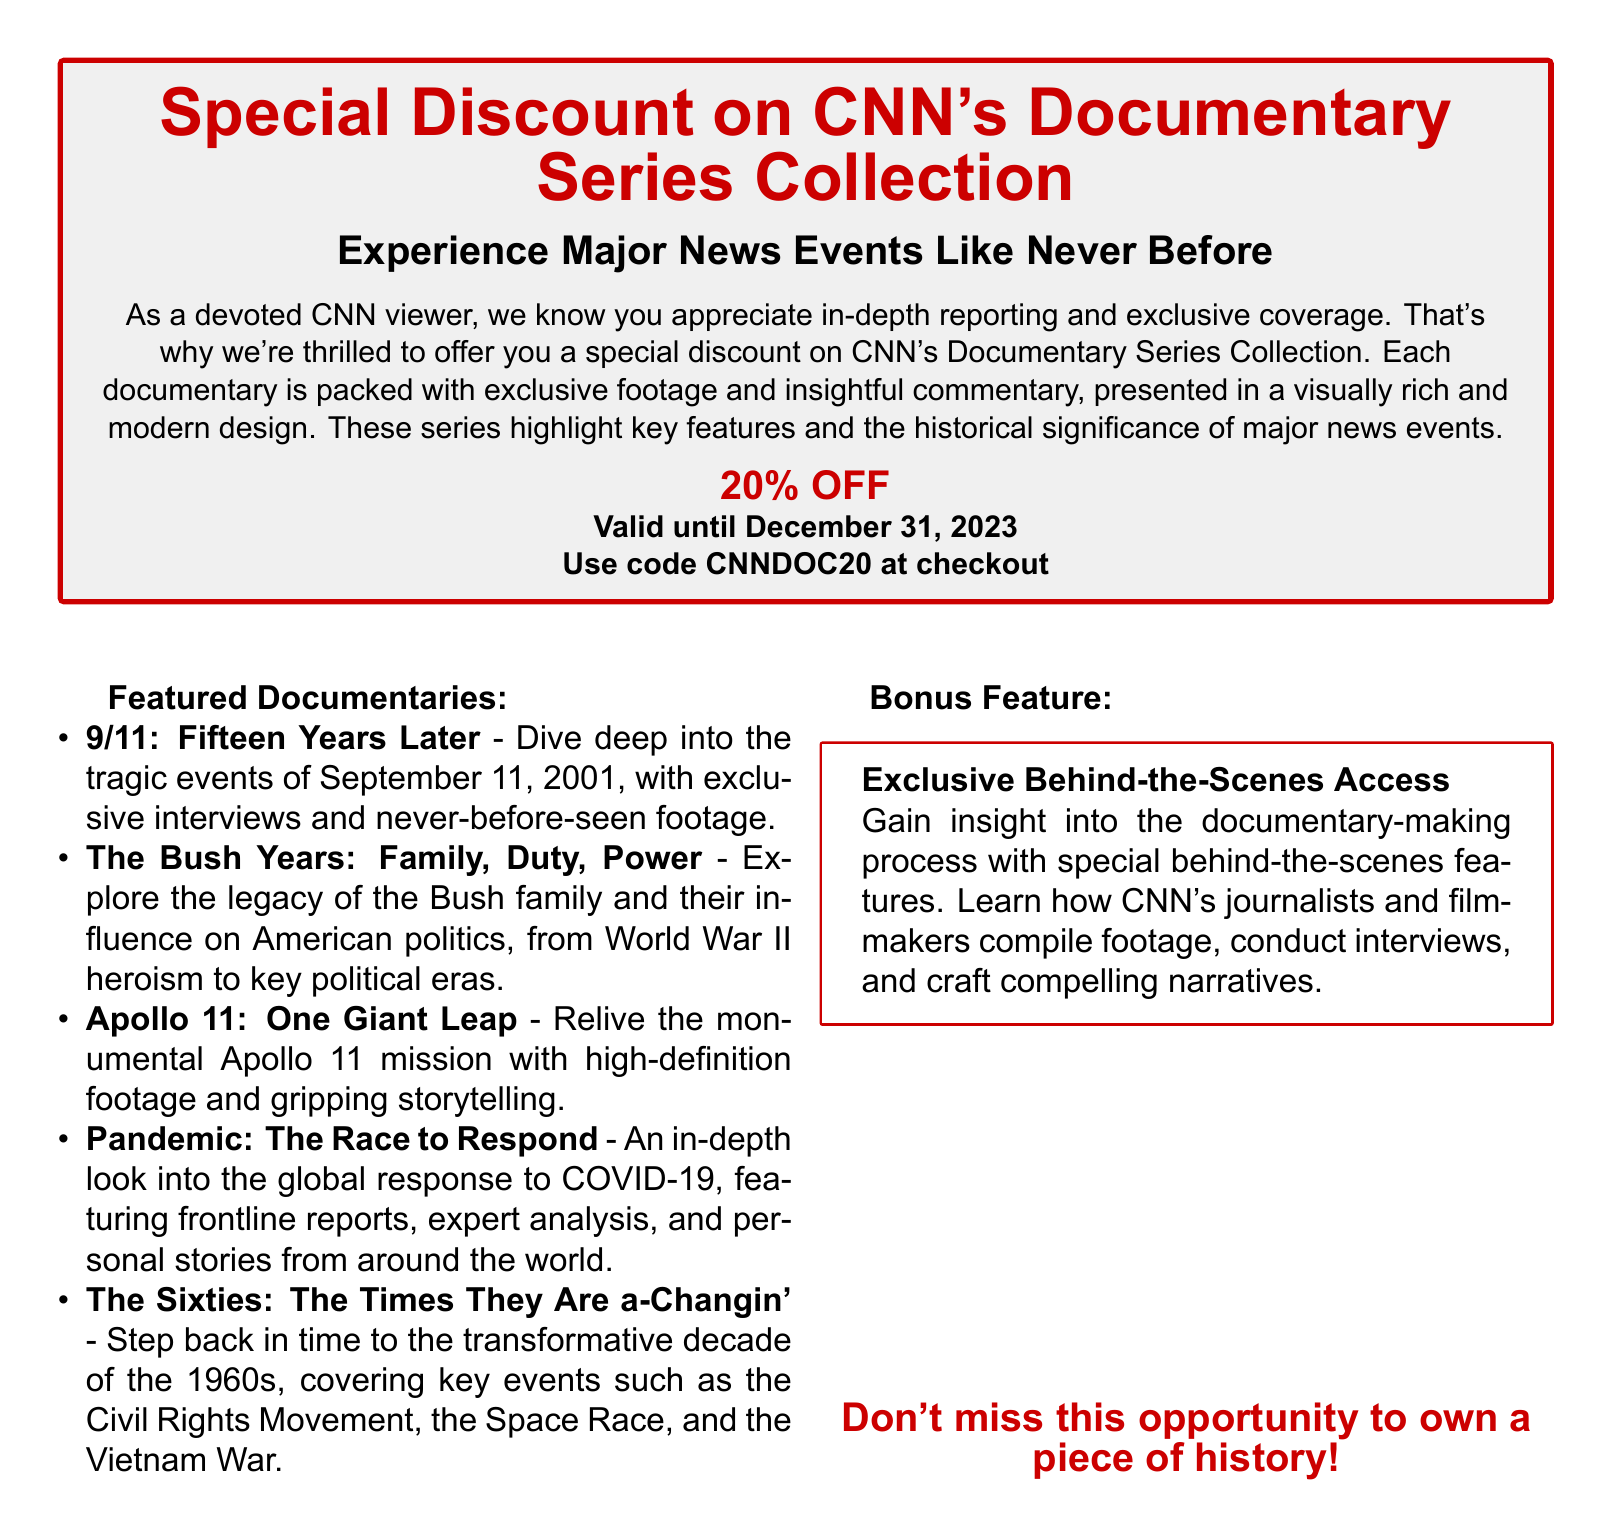What is the discount percentage offered? The document states the discount percentage as "20% OFF."
Answer: 20% OFF What is the validity period of the voucher? The document mentions that the voucher is "Valid until December 31, 2023."
Answer: December 31, 2023 What code should be used at checkout? The document specifies to use the code "CNNDOC20" at checkout.
Answer: CNNDOC20 Which documentary covers the Apollo 11 mission? The document lists "Apollo 11: One Giant Leap" as the documentary covering the Apollo 11 mission.
Answer: Apollo 11: One Giant Leap What feature provides behind-the-scenes insight? The document refers to "Exclusive Behind-the-Scenes Access" as the feature providing insight into the documentary-making process.
Answer: Exclusive Behind-the-Scenes Access 